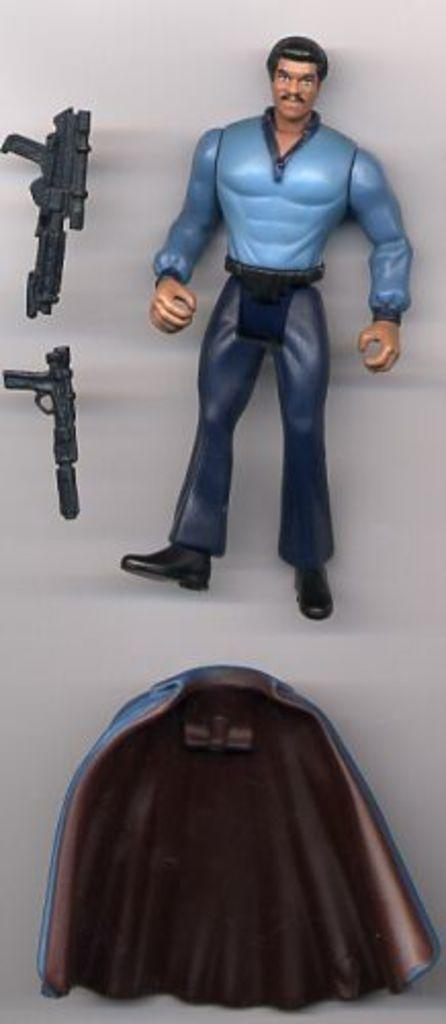What type of toy is present in the image? There is a toy of a person in the image. What weapons are visible in the image? There are two guns in the image. Can you describe the unspecified object in the image? Unfortunately, the provided facts do not give enough information to describe the unspecified object in the image. How does the toy person walk in the image? The toy person does not walk in the image, as it is an inanimate object. 